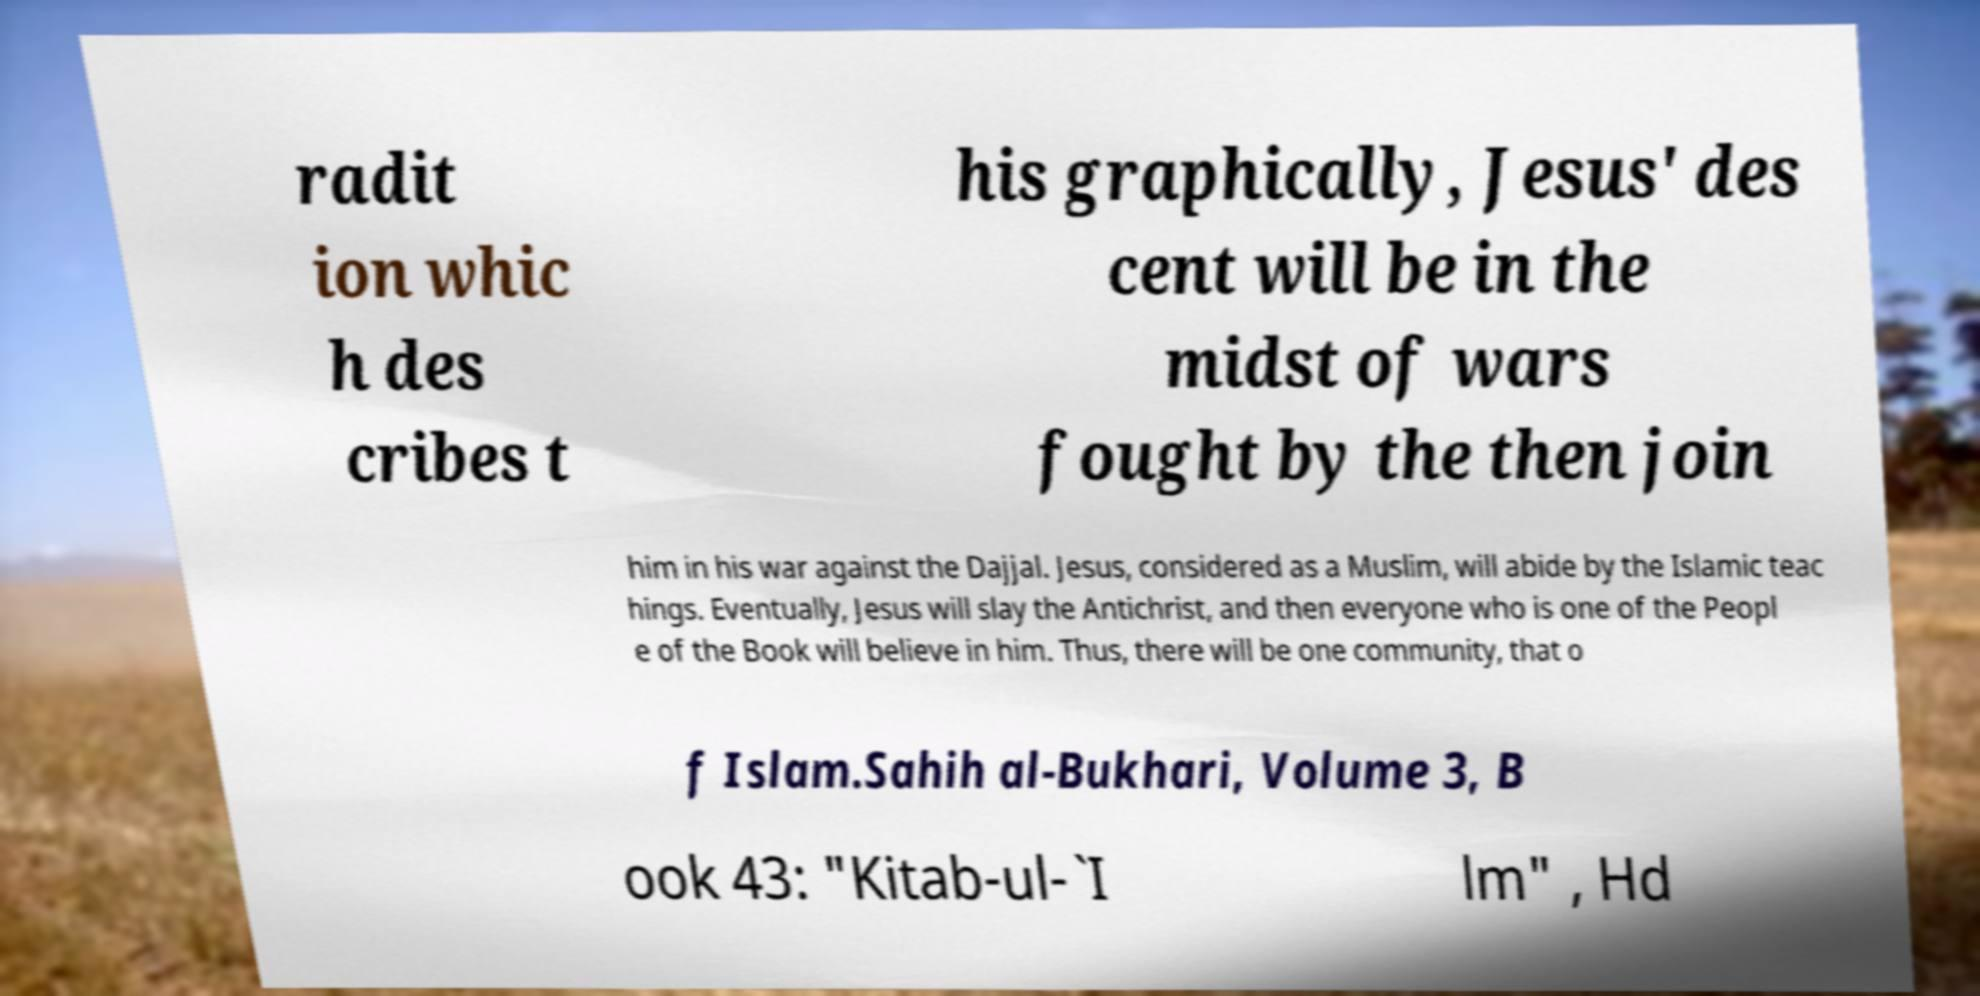What messages or text are displayed in this image? I need them in a readable, typed format. radit ion whic h des cribes t his graphically, Jesus' des cent will be in the midst of wars fought by the then join him in his war against the Dajjal. Jesus, considered as a Muslim, will abide by the Islamic teac hings. Eventually, Jesus will slay the Antichrist, and then everyone who is one of the Peopl e of the Book will believe in him. Thus, there will be one community, that o f Islam.Sahih al-Bukhari, Volume 3, B ook 43: "Kitab-ul-`I lm" , Hd 